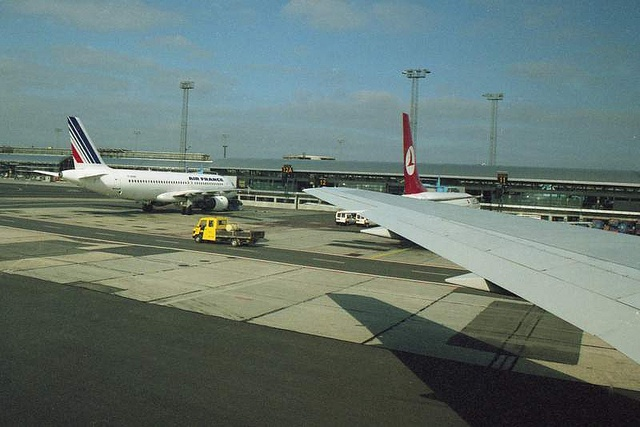Describe the objects in this image and their specific colors. I can see airplane in gray, darkgray, and lightgray tones, airplane in gray, lightgray, darkgray, and black tones, airplane in gray, maroon, darkgray, and lightgray tones, and truck in gray, black, darkgreen, and olive tones in this image. 